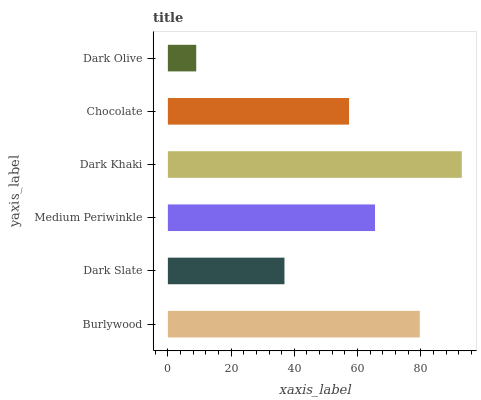Is Dark Olive the minimum?
Answer yes or no. Yes. Is Dark Khaki the maximum?
Answer yes or no. Yes. Is Dark Slate the minimum?
Answer yes or no. No. Is Dark Slate the maximum?
Answer yes or no. No. Is Burlywood greater than Dark Slate?
Answer yes or no. Yes. Is Dark Slate less than Burlywood?
Answer yes or no. Yes. Is Dark Slate greater than Burlywood?
Answer yes or no. No. Is Burlywood less than Dark Slate?
Answer yes or no. No. Is Medium Periwinkle the high median?
Answer yes or no. Yes. Is Chocolate the low median?
Answer yes or no. Yes. Is Dark Khaki the high median?
Answer yes or no. No. Is Medium Periwinkle the low median?
Answer yes or no. No. 